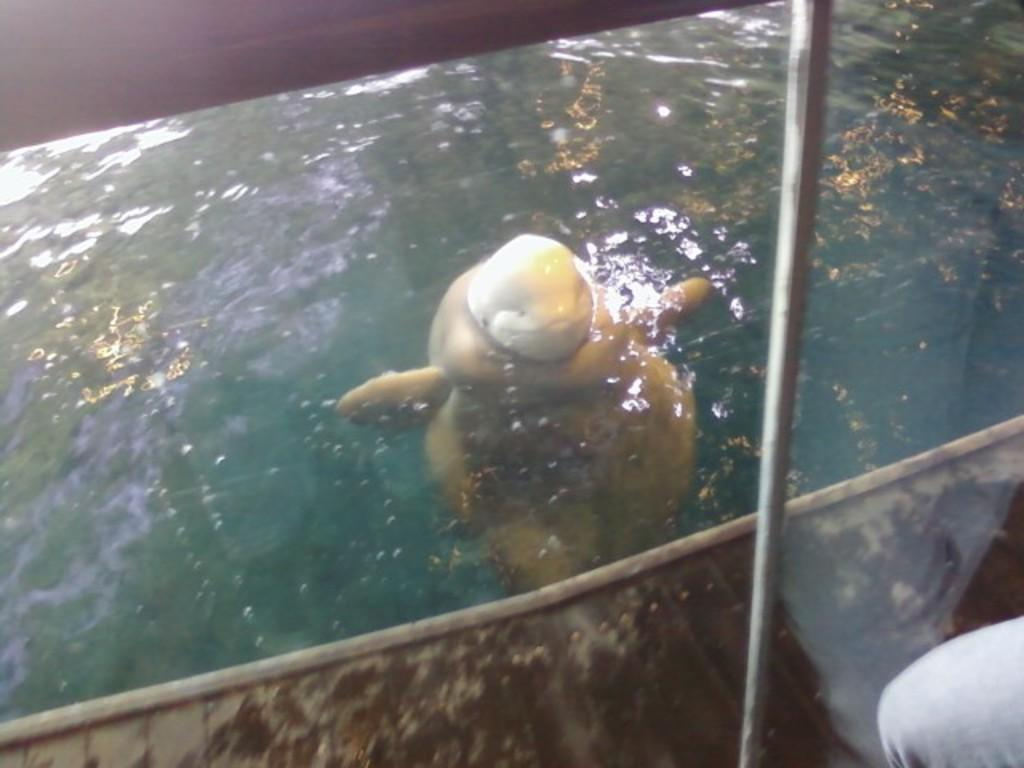What is the main subject of the image? There is a yellow creature in the water. Can you describe the creature's location in the image? The yellow creature is in the water. Is there any other person or object visible in the image? Yes, a person's leg is visible in the bottom right corner of the image. How many boats can be seen in the image? There are no boats visible in the image. What type of spot is present on the creature's back? There is no spot visible on the creature's back, as the image does not provide enough detail to determine this. 